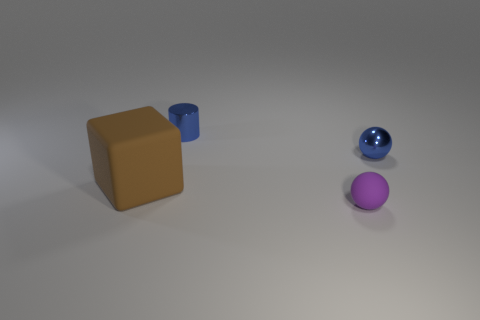Could the arrangement of these objects suggest any specific concept or idea? One possible interpretation is that the arrangement represents diversity and individuality, each object with its unique shape and color, standing apart yet part of a collective set up. Alternatively, it may suggest a discussion on dimensionality or geometric forms. Is there a sense of balance in the composition of this image? The composition does convey a sense of balance. The objects are evenly distributed across the scene, and their varying shapes and colors create a harmonious visual balance without any single object dominating the viewpoint. 